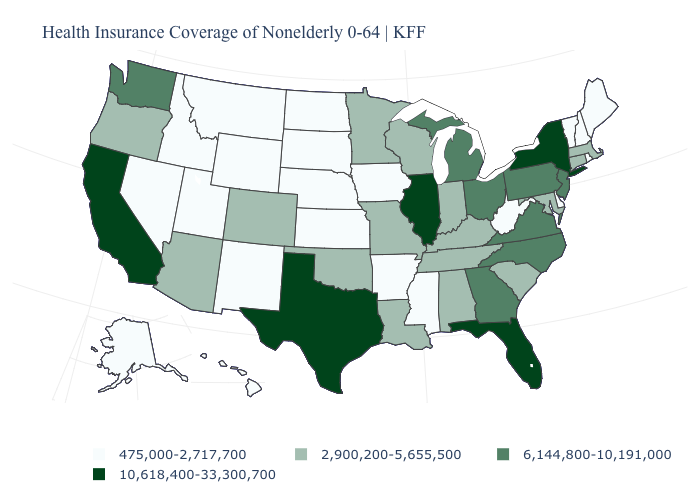Does the first symbol in the legend represent the smallest category?
Keep it brief. Yes. What is the value of Mississippi?
Write a very short answer. 475,000-2,717,700. Name the states that have a value in the range 6,144,800-10,191,000?
Write a very short answer. Georgia, Michigan, New Jersey, North Carolina, Ohio, Pennsylvania, Virginia, Washington. Name the states that have a value in the range 475,000-2,717,700?
Concise answer only. Alaska, Arkansas, Delaware, Hawaii, Idaho, Iowa, Kansas, Maine, Mississippi, Montana, Nebraska, Nevada, New Hampshire, New Mexico, North Dakota, Rhode Island, South Dakota, Utah, Vermont, West Virginia, Wyoming. What is the lowest value in states that border New Mexico?
Give a very brief answer. 475,000-2,717,700. Which states have the lowest value in the MidWest?
Short answer required. Iowa, Kansas, Nebraska, North Dakota, South Dakota. Does Washington have a lower value than Illinois?
Write a very short answer. Yes. Does New York have the highest value in the Northeast?
Quick response, please. Yes. Name the states that have a value in the range 10,618,400-33,300,700?
Be succinct. California, Florida, Illinois, New York, Texas. What is the value of California?
Quick response, please. 10,618,400-33,300,700. Name the states that have a value in the range 10,618,400-33,300,700?
Give a very brief answer. California, Florida, Illinois, New York, Texas. Name the states that have a value in the range 10,618,400-33,300,700?
Keep it brief. California, Florida, Illinois, New York, Texas. Name the states that have a value in the range 10,618,400-33,300,700?
Answer briefly. California, Florida, Illinois, New York, Texas. What is the value of West Virginia?
Answer briefly. 475,000-2,717,700. 